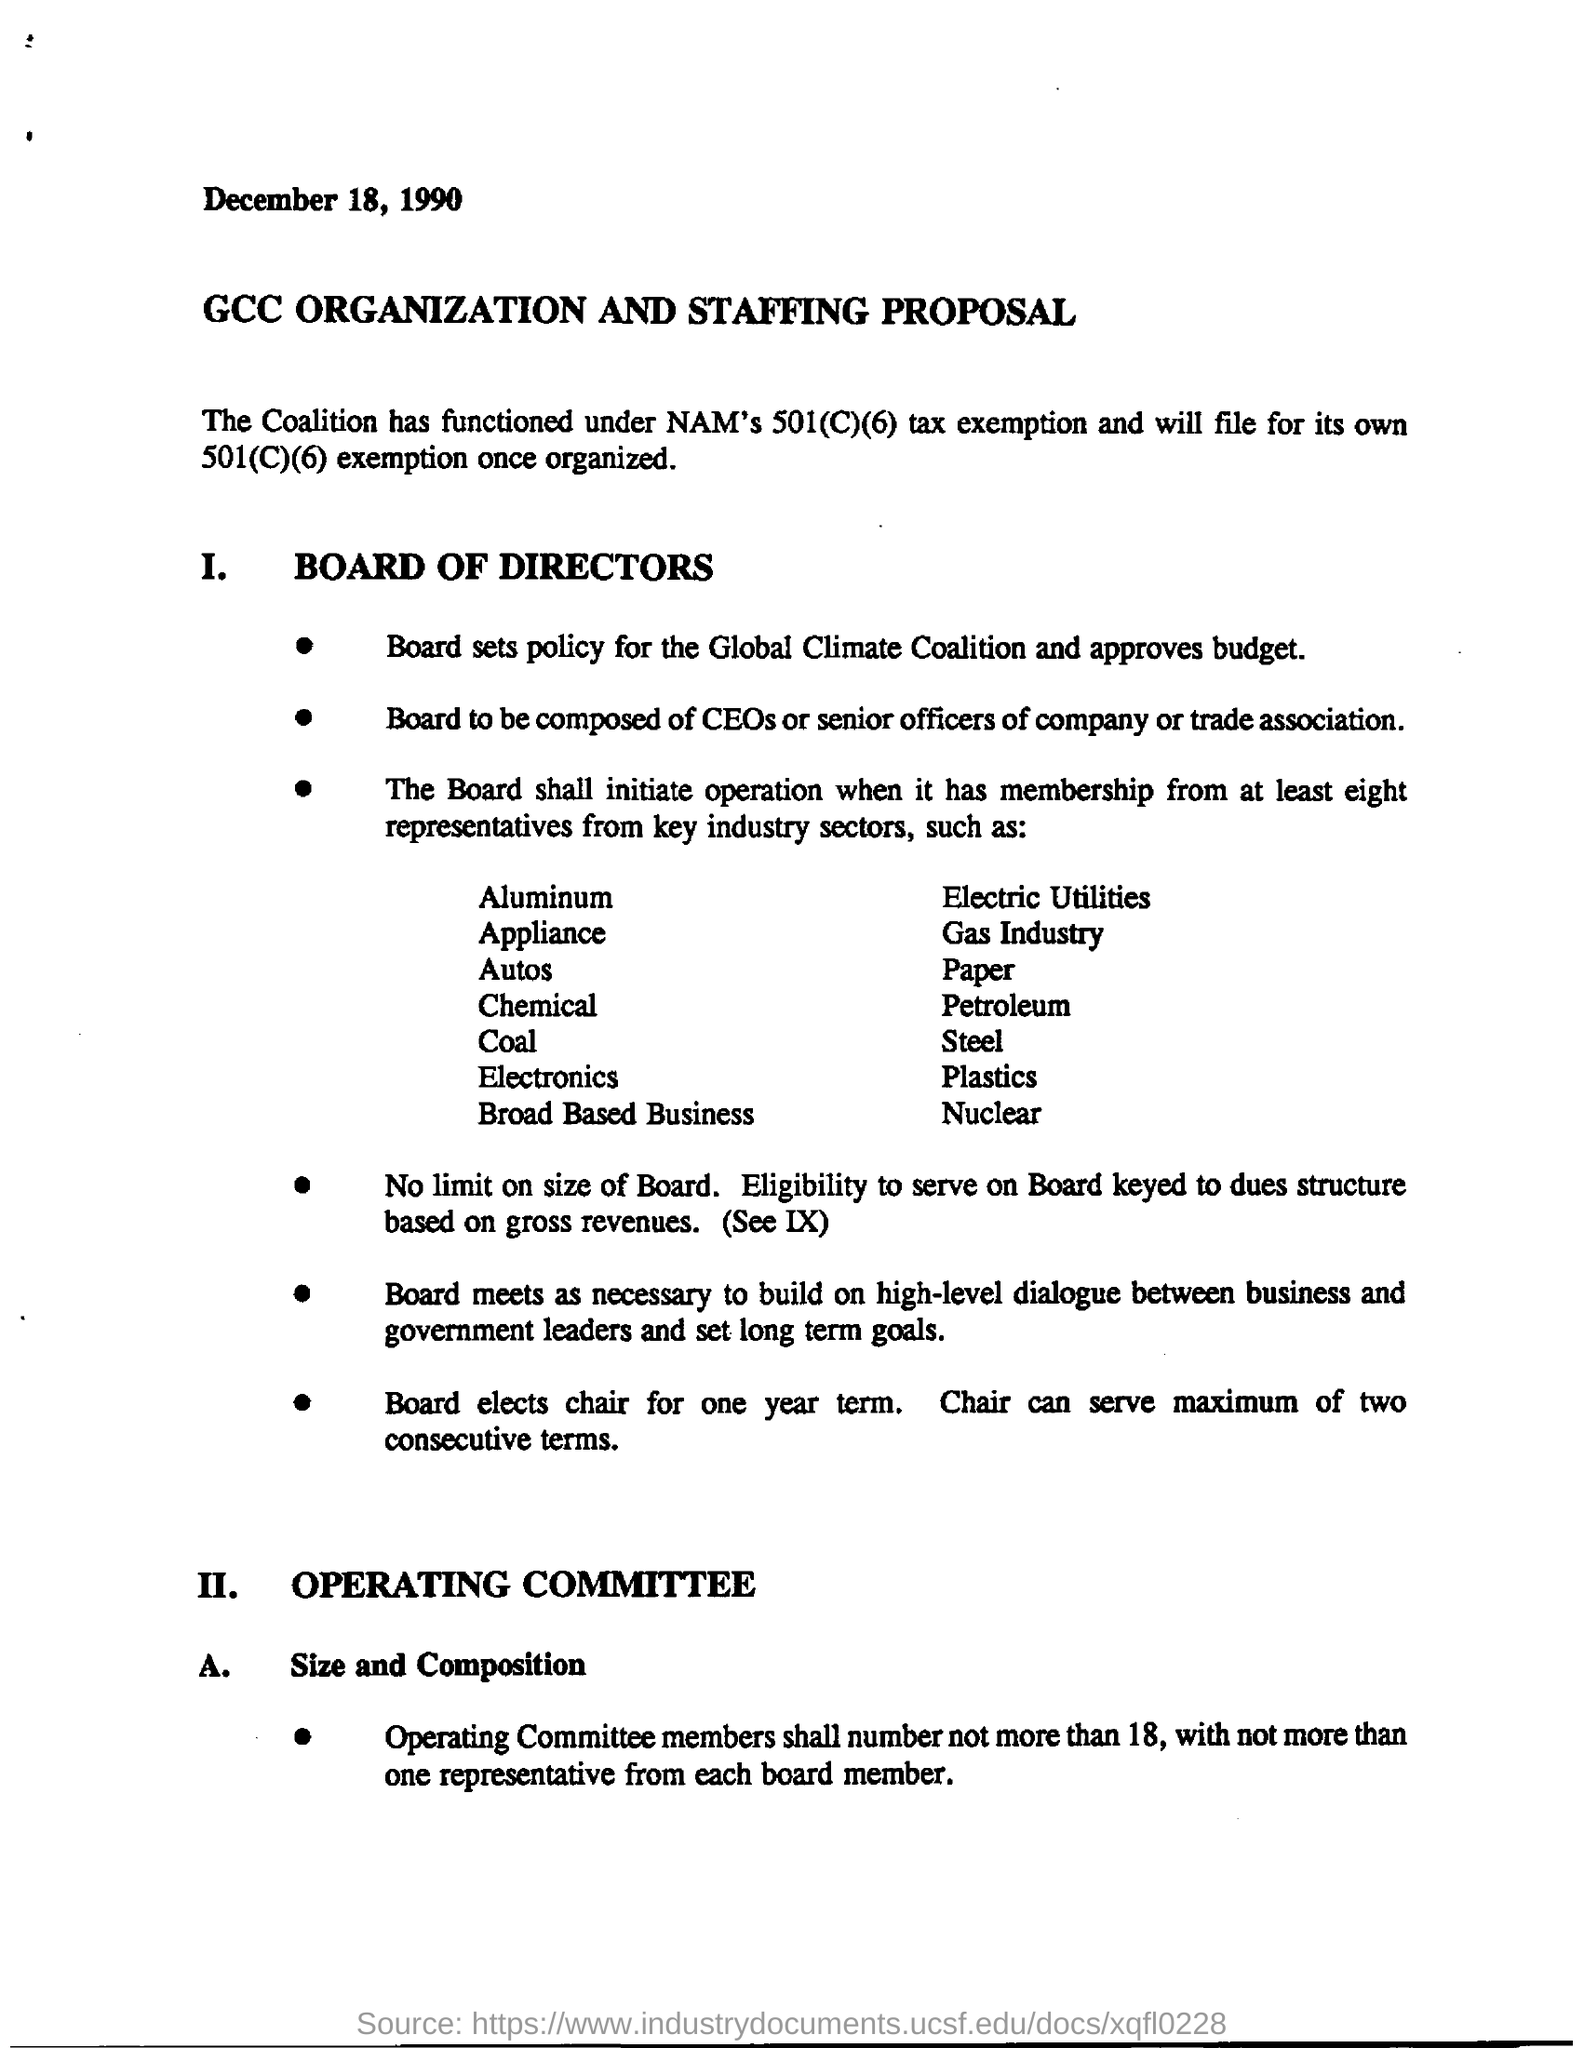Mention a couple of crucial points in this snapshot. The date mentioned in the document is December 18, 1990. The document is titled "GCC Organization and Staffing Proposal. 